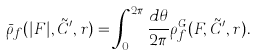Convert formula to latex. <formula><loc_0><loc_0><loc_500><loc_500>\bar { \rho } _ { f } ( | F | , \tilde { C } ^ { \prime } , r ) = \int _ { 0 } ^ { 2 \pi } \frac { d \theta } { 2 \pi } \rho _ { f } ^ { G } ( F , \tilde { C } ^ { \prime } , r ) .</formula> 